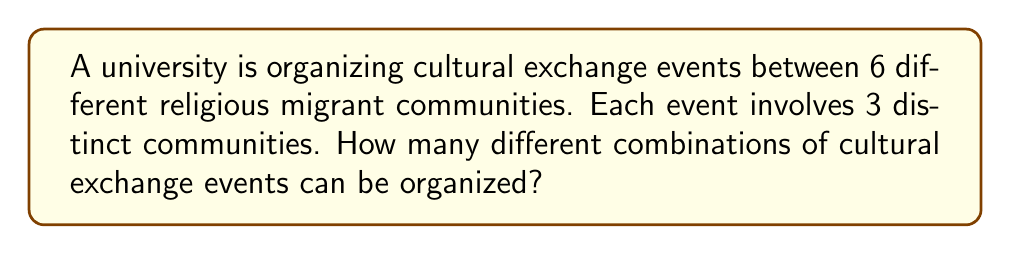Provide a solution to this math problem. To solve this problem, we need to use the combination formula from combinatorics. We are selecting 3 communities out of 6, where the order doesn't matter (as it's a combination, not a permutation).

The formula for combinations is:

$$ C(n,r) = \frac{n!}{r!(n-r)!} $$

Where:
$n$ is the total number of items to choose from (in this case, 6 religious migrant communities)
$r$ is the number of items being chosen (in this case, 3 communities per event)

Let's plug in our values:

$$ C(6,3) = \frac{6!}{3!(6-3)!} = \frac{6!}{3!3!} $$

Now, let's calculate this step-by-step:

1) $6! = 6 \times 5 \times 4 \times 3 \times 2 \times 1 = 720$
2) $3! = 3 \times 2 \times 1 = 6$

So, our equation becomes:

$$ \frac{720}{6 \times 6} = \frac{720}{36} = 20 $$

Therefore, there are 20 different combinations of cultural exchange events that can be organized.
Answer: 20 